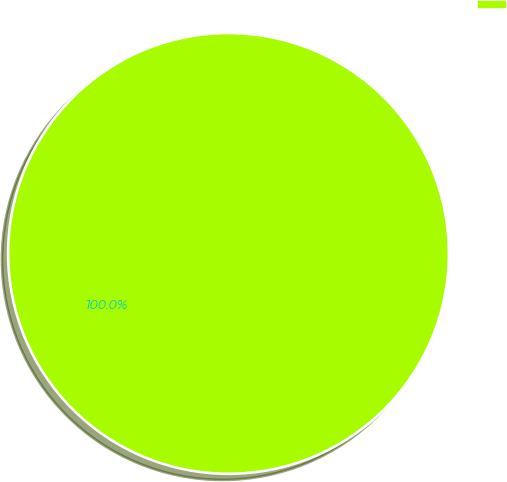Convert chart. <chart><loc_0><loc_0><loc_500><loc_500><pie_chart><ecel><nl><fcel>100.0%<nl></chart> 